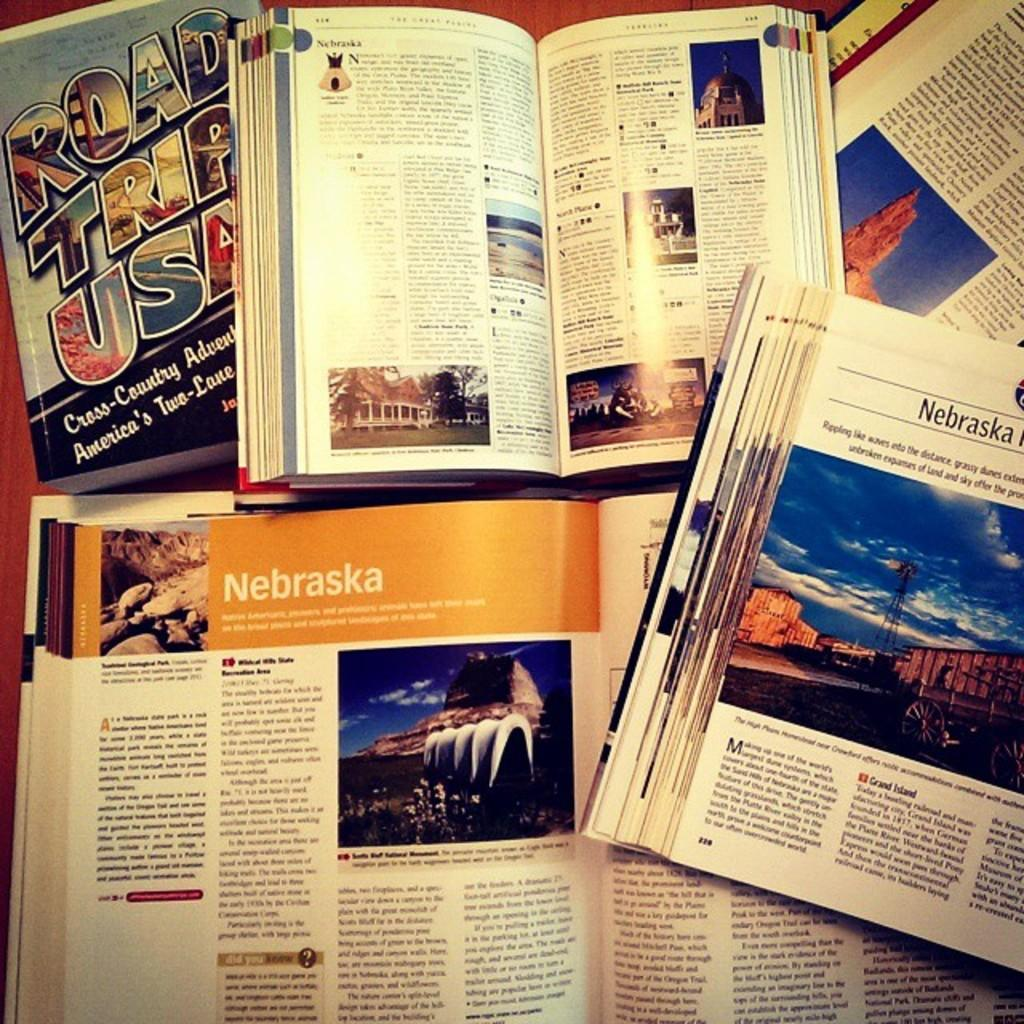<image>
Provide a brief description of the given image. A Nebraska vacation guide has a section devoted to the location known as Grand Island. 